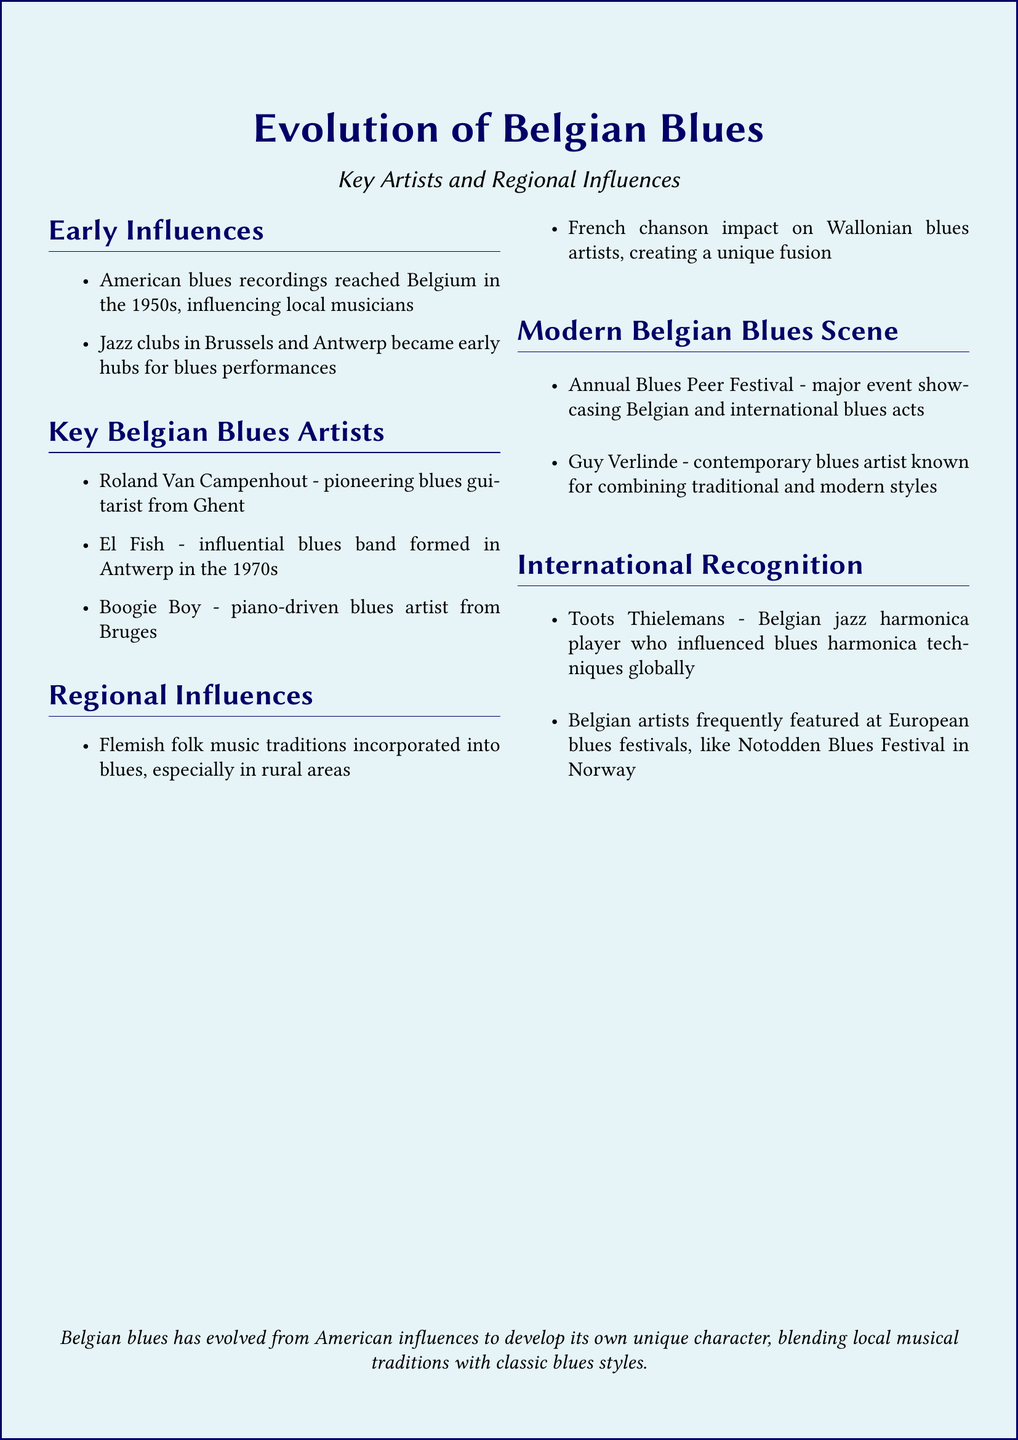what decade did American blues recordings reach Belgium? The document states that American blues recordings began to influence local musicians in the 1950s.
Answer: 1950s who is a pioneering blues guitarist from Ghent? The document lists Roland Van Campenhout as a pioneering blues guitarist from Ghent.
Answer: Roland Van Campenhout what city is the annual Blues Peer Festival held in? The document mentions the Blues Peer Festival as a major event but does not specify the city; it's important for readers to infer that it occurs in Peer, Belgium.
Answer: Peer which Belgian artist is known for combining traditional and modern styles? The document references Guy Verlinde as a contemporary blues artist known for this combination.
Answer: Guy Verlinde how is Flemish folk music described in relation to Belgian blues? The document states that Flemish folk music traditions are incorporated into blues, especially in rural areas.
Answer: Incorporated into blues what musical influence is noted for Wallonian blues artists? The document indicates that French chanson has an impact on Wallonian blues artists, creating a unique fusion.
Answer: French chanson who was a Belgian jazz harmonica player influential in blues harmonica techniques? The document highlights Toots Thielemans as a Belgian jazz harmonica player who influenced these techniques globally.
Answer: Toots Thielemans in what city was the influential blues band El Fish formed? The document identifies Antwerp as the formation city for the influential blues band El Fish in the 1970s.
Answer: Antwerp what is the relationship between American influences and Belgian blues according to the conclusion? The conclusion summarizes that Belgian blues has evolved from American influences to develop its own unique character.
Answer: Evolved from American influences 